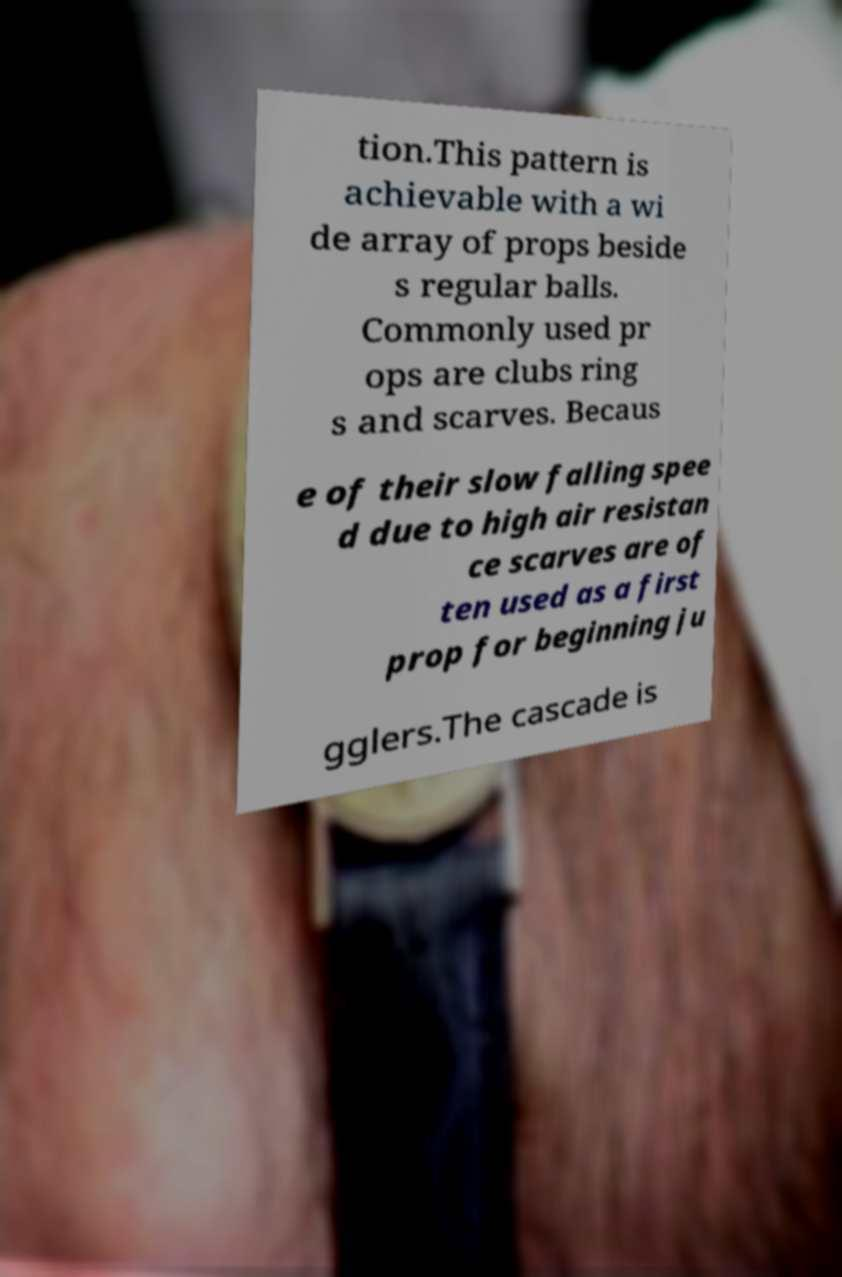Could you extract and type out the text from this image? tion.This pattern is achievable with a wi de array of props beside s regular balls. Commonly used pr ops are clubs ring s and scarves. Becaus e of their slow falling spee d due to high air resistan ce scarves are of ten used as a first prop for beginning ju gglers.The cascade is 